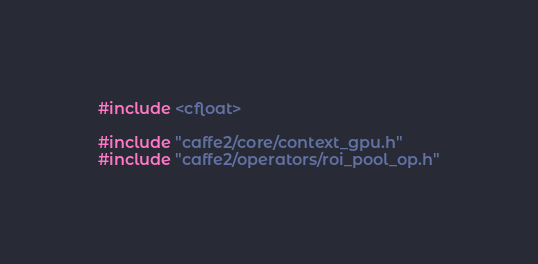<code> <loc_0><loc_0><loc_500><loc_500><_Cuda_>#include <cfloat>

#include "caffe2/core/context_gpu.h"
#include "caffe2/operators/roi_pool_op.h"
</code> 